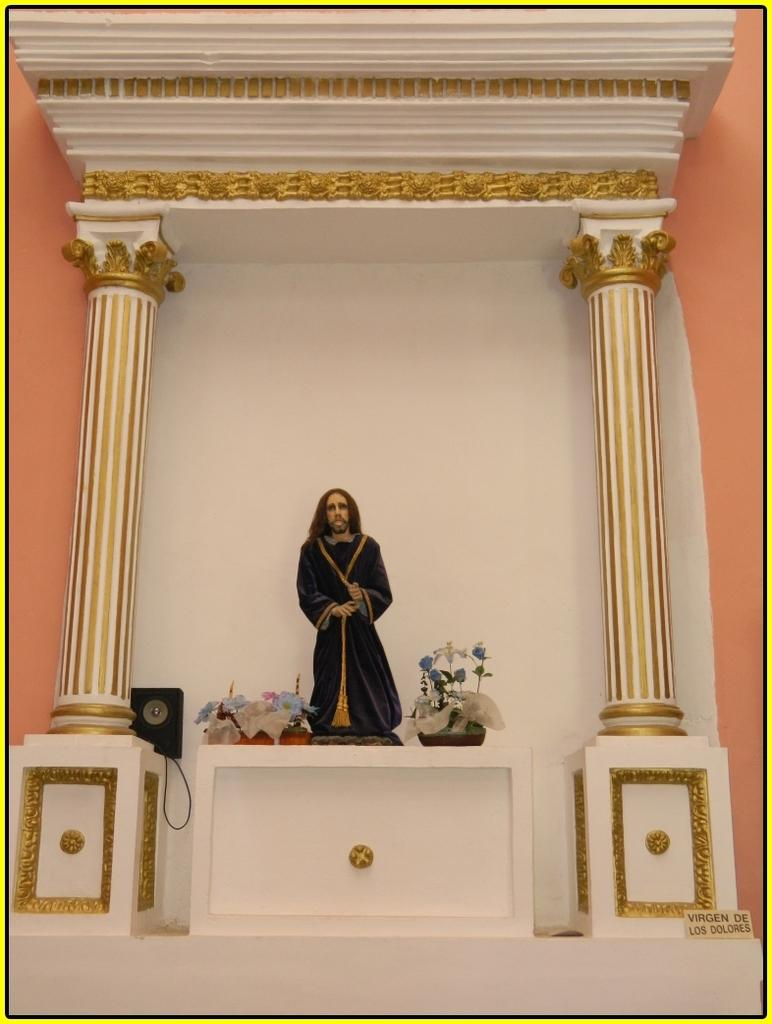What is the main subject of the image? There is a statue of a person in the image. What architectural features can be seen in the image? There are 2 pillars in the image. What object is present for amplifying sound? There is a speaker in the image. What color is the background of the image? The background of the image is white. Can you tell me how the cream is being used in the image? There is no cream present in the image. What type of wind can be seen blowing the statue in the image? There is no wind or blowing force depicted in the image; the statue is stationary. 